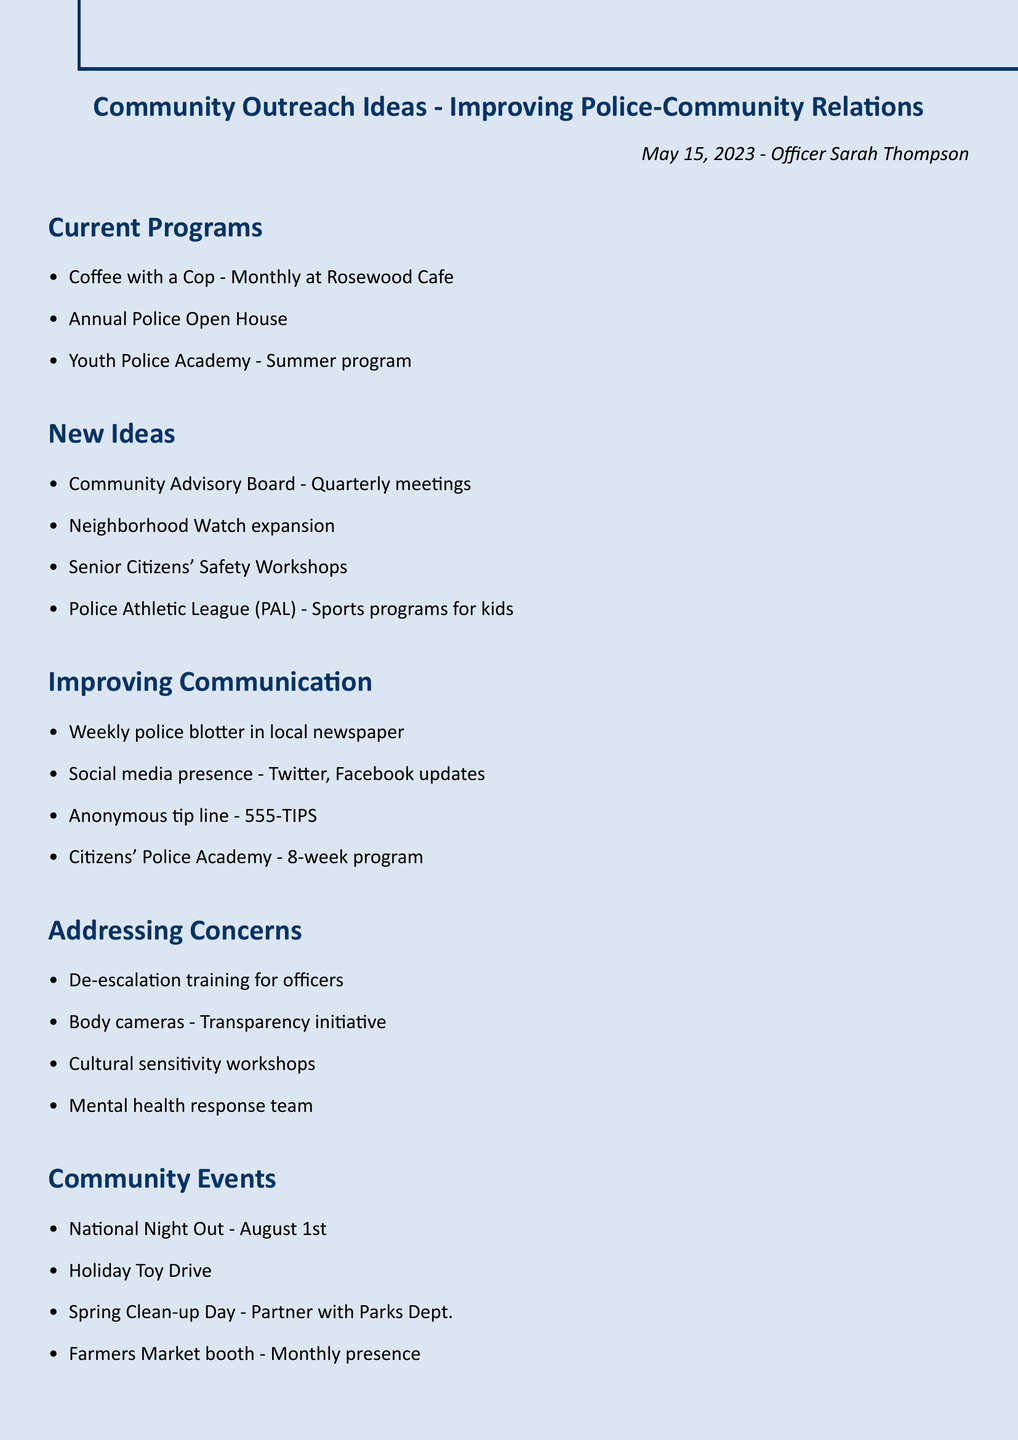what is the title of the document? The title is mentioned at the top of the document as "Community Outreach Ideas - Improving Police-Community Relations."
Answer: Community Outreach Ideas - Improving Police-Community Relations who is the author of the notes? The author's name is provided in the document as "Officer Sarah Thompson."
Answer: Officer Sarah Thompson how often is Coffee with a Cop held? The document states that Coffee with a Cop is a monthly event.
Answer: Monthly what is one of the new ideas proposed for improving police-community relations? The document lists several new ideas, one of which is the "Community Advisory Board - Quarterly meetings."
Answer: Community Advisory Board - Quarterly meetings when is National Night Out scheduled? The date for National Night Out is specified in the document as August 1st.
Answer: August 1st which program is suggested for kids under New Ideas? The document includes the "Police Athletic League (PAL) - Sports programs for kids" under New Ideas.
Answer: Police Athletic League (PAL) - Sports programs for kids how many action items are listed in the document? The total number of action items is counted from the Action Items section, which contains four items.
Answer: 4 what initiative is mentioned for addressing transparency? The document specifically mentions "Body cameras - Transparency initiative" as an initiative for addressing transparency.
Answer: Body cameras - Transparency initiative what type of workshop is proposed for senior citizens? The document includes "Senior Citizens' Safety Workshops" under New Ideas.
Answer: Senior Citizens' Safety Workshops 